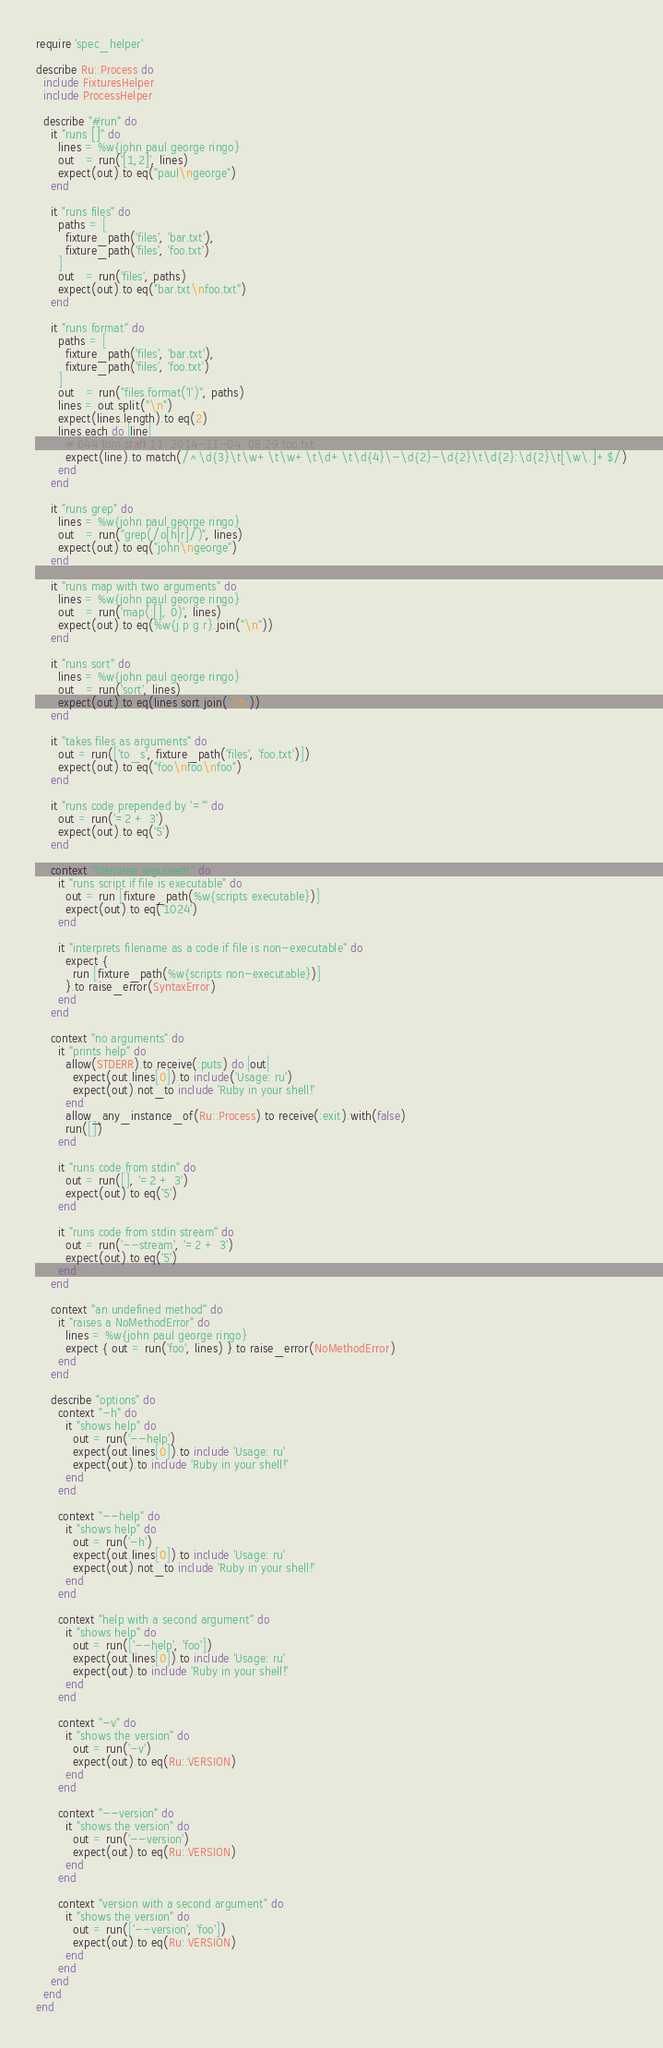<code> <loc_0><loc_0><loc_500><loc_500><_Ruby_>require 'spec_helper'

describe Ru::Process do
  include FixturesHelper
  include ProcessHelper

  describe "#run" do
    it "runs []" do
      lines = %w{john paul george ringo}
      out   = run('[1,2]', lines)
      expect(out).to eq("paul\ngeorge")
    end

    it "runs files" do
      paths = [
        fixture_path('files', 'bar.txt'),
        fixture_path('files', 'foo.txt')
      ]
      out   = run('files', paths)
      expect(out).to eq("bar.txt\nfoo.txt")
    end

    it "runs format" do
      paths = [
        fixture_path('files', 'bar.txt'),
        fixture_path('files', 'foo.txt')
      ]
      out   = run("files.format('l')", paths)
      lines = out.split("\n")
      expect(lines.length).to eq(2)
      lines.each do |line|
        # 644 tom staff 11  2014-11-04  08:29 foo.txt
        expect(line).to match(/^\d{3}\t\w+\t\w+\t\d+\t\d{4}\-\d{2}-\d{2}\t\d{2}:\d{2}\t[\w\.]+$/)
      end
    end

    it "runs grep" do
      lines = %w{john paul george ringo}
      out   = run("grep(/o[h|r]/)", lines)
      expect(out).to eq("john\ngeorge")
    end

    it "runs map with two arguments" do
      lines = %w{john paul george ringo}
      out   = run('map(:[], 0)', lines)
      expect(out).to eq(%w{j p g r}.join("\n"))
    end

    it "runs sort" do
      lines = %w{john paul george ringo}
      out   = run('sort', lines)
      expect(out).to eq(lines.sort.join("\n"))
    end

    it "takes files as arguments" do
      out = run(['to_s', fixture_path('files', 'foo.txt')])
      expect(out).to eq("foo\nfoo\nfoo")
    end

    it "runs code prepended by '='" do
      out = run('=2 + 3')
      expect(out).to eq('5')
    end

    context "filename argument" do
      it "runs script if file is executable" do
        out = run [fixture_path(%w{scripts executable})]
        expect(out).to eq('1024')
      end

      it "interprets filename as a code if file is non-executable" do
        expect {
          run [fixture_path(%w{scripts non-executable})]
        }.to raise_error(SyntaxError)
      end
    end

    context "no arguments" do
      it "prints help" do
        allow(STDERR).to receive(:puts) do |out|
          expect(out.lines[0]).to include('Usage: ru')
          expect(out).not_to include 'Ruby in your shell!'
        end
        allow_any_instance_of(Ru::Process).to receive(:exit).with(false)
        run([])
      end

      it "runs code from stdin" do
        out = run([], '=2 + 3')
        expect(out).to eq('5')
      end

      it "runs code from stdin stream" do
        out = run('--stream', '=2 + 3')
        expect(out).to eq('5')
      end
    end

    context "an undefined method" do
      it "raises a NoMethodError" do
        lines = %w{john paul george ringo}
        expect { out = run('foo', lines) }.to raise_error(NoMethodError)
      end
    end

    describe "options" do
      context "-h" do
        it "shows help" do
          out = run('--help')
          expect(out.lines[0]).to include 'Usage: ru'
          expect(out).to include 'Ruby in your shell!'
        end
      end

      context "--help" do
        it "shows help" do
          out = run('-h')
          expect(out.lines[0]).to include 'Usage: ru'
          expect(out).not_to include 'Ruby in your shell!'
        end
      end

      context "help with a second argument" do
        it "shows help" do
          out = run(['--help', 'foo'])
          expect(out.lines[0]).to include 'Usage: ru'
          expect(out).to include 'Ruby in your shell!'
        end
      end

      context "-v" do
        it "shows the version" do
          out = run('-v')
          expect(out).to eq(Ru::VERSION)
        end
      end

      context "--version" do
        it "shows the version" do
          out = run('--version')
          expect(out).to eq(Ru::VERSION)
        end
      end

      context "version with a second argument" do
        it "shows the version" do
          out = run(['--version', 'foo'])
          expect(out).to eq(Ru::VERSION)
        end
      end
    end
  end
end
</code> 